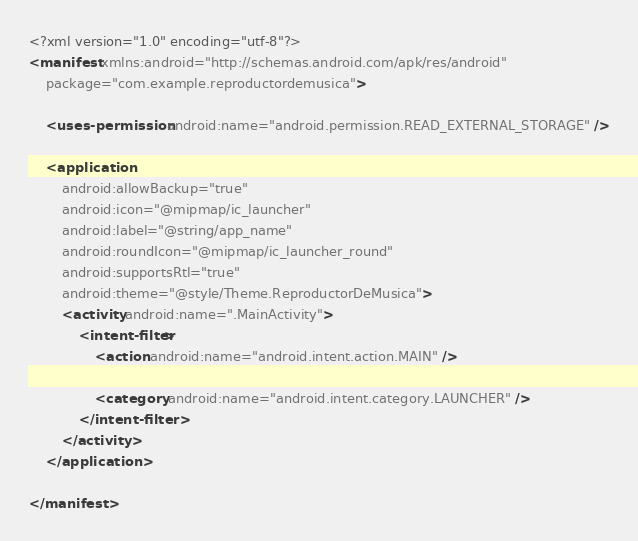<code> <loc_0><loc_0><loc_500><loc_500><_XML_><?xml version="1.0" encoding="utf-8"?>
<manifest xmlns:android="http://schemas.android.com/apk/res/android"
    package="com.example.reproductordemusica">

    <uses-permission android:name="android.permission.READ_EXTERNAL_STORAGE" />

    <application
        android:allowBackup="true"
        android:icon="@mipmap/ic_launcher"
        android:label="@string/app_name"
        android:roundIcon="@mipmap/ic_launcher_round"
        android:supportsRtl="true"
        android:theme="@style/Theme.ReproductorDeMusica">
        <activity android:name=".MainActivity">
            <intent-filter>
                <action android:name="android.intent.action.MAIN" />

                <category android:name="android.intent.category.LAUNCHER" />
            </intent-filter>
        </activity>
    </application>

</manifest></code> 